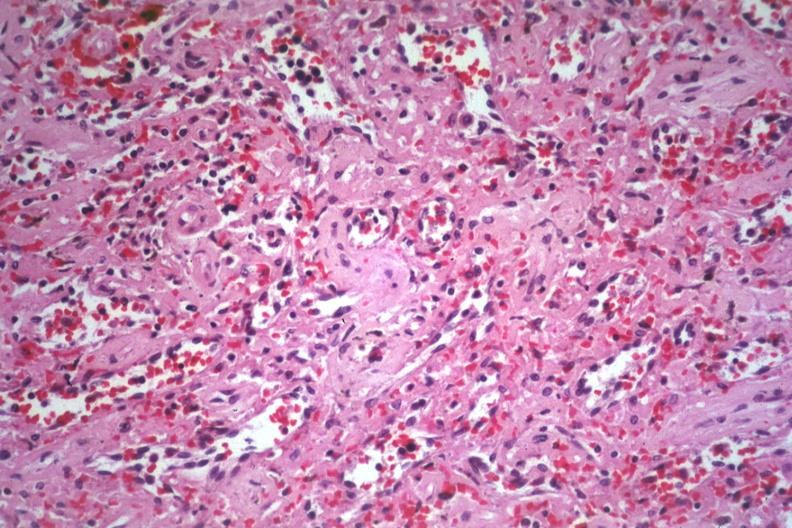s hemorrhage in newborn present?
Answer the question using a single word or phrase. No 